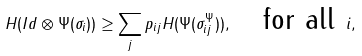Convert formula to latex. <formula><loc_0><loc_0><loc_500><loc_500>H ( I d \otimes \Psi ( \sigma _ { i } ) ) \geq \sum _ { j } p _ { i j } H ( \Psi ( \sigma _ { i j } ^ { \Psi } ) ) , \quad \text {for all } i ,</formula> 